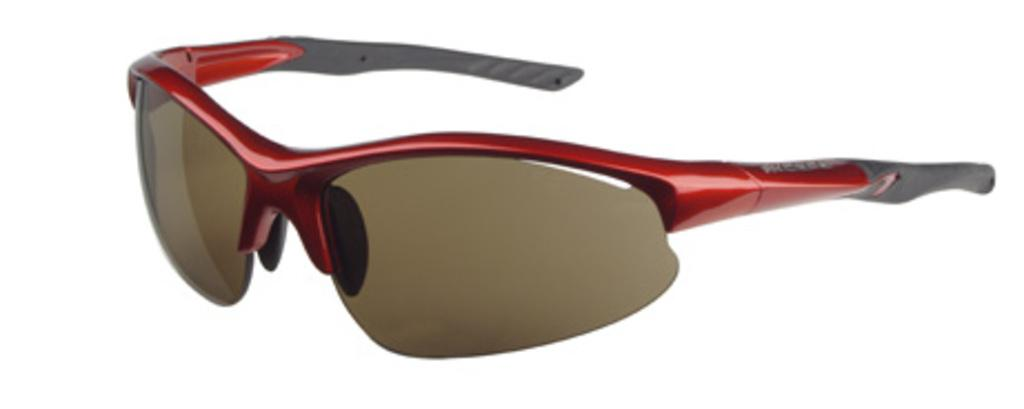What type of accessory is present in the image? There are goggles in the image. What is the color of the goggles' frame? The frame of the goggles is red in color. What other color can be seen on the goggles? Some parts of the goggles are gray in color. What type of soup is being served on the hill in the image? There is no soup or hill present in the image; it only features goggles. 